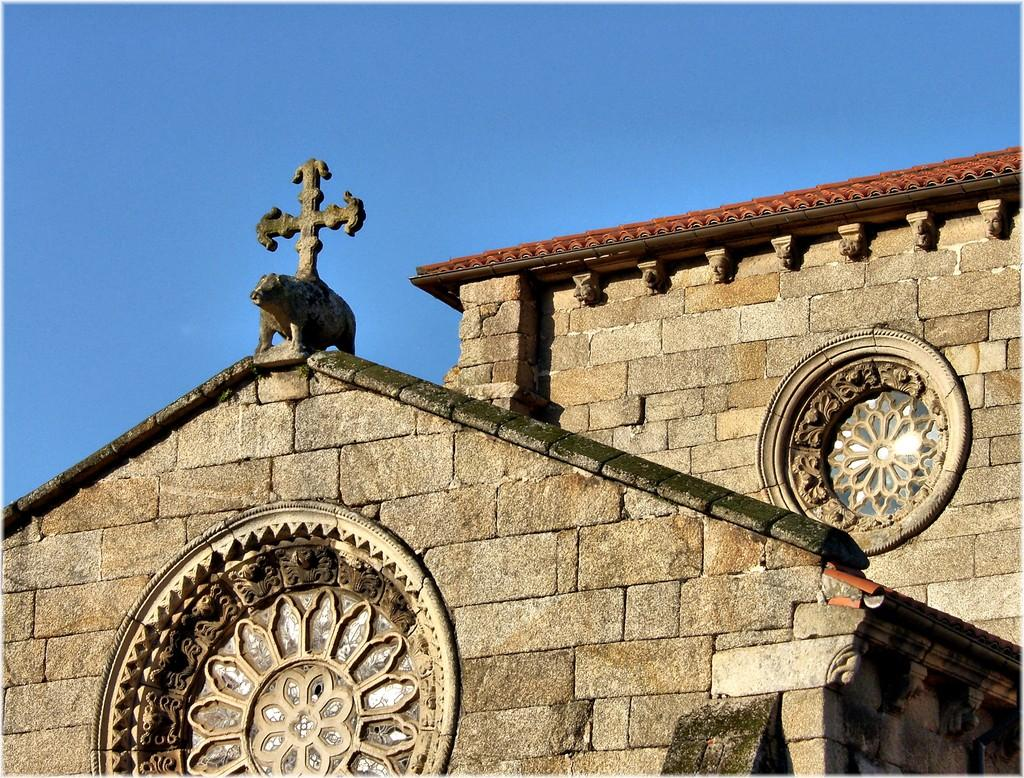What is the main structure in the image? There is a building in the image. What is on the building? There is a sculpture on the building. What can be seen in the background of the image? The sky is visible in the background of the image. What type of nut is being mined in the image? There is no mine or nut present in the image; it features a building with a sculpture and a visible sky. 